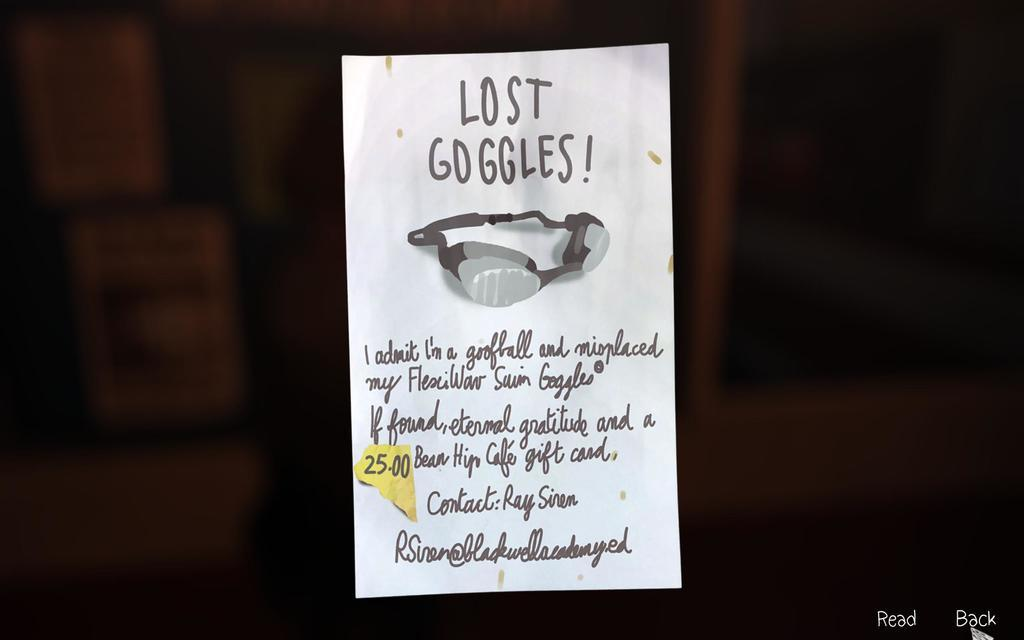What is present on the paper note in the image? There is a paper note in the image, with text written on it and a Google image. Can you describe the content of the text on the paper note? Unfortunately, the specific content of the text cannot be determined from the image alone. What type of image is on the paper note? The image on the paper note is a Google image. How many legs are visible on the paper note in the image? There are no legs visible on the paper note, as it is a flat, two-dimensional object. 